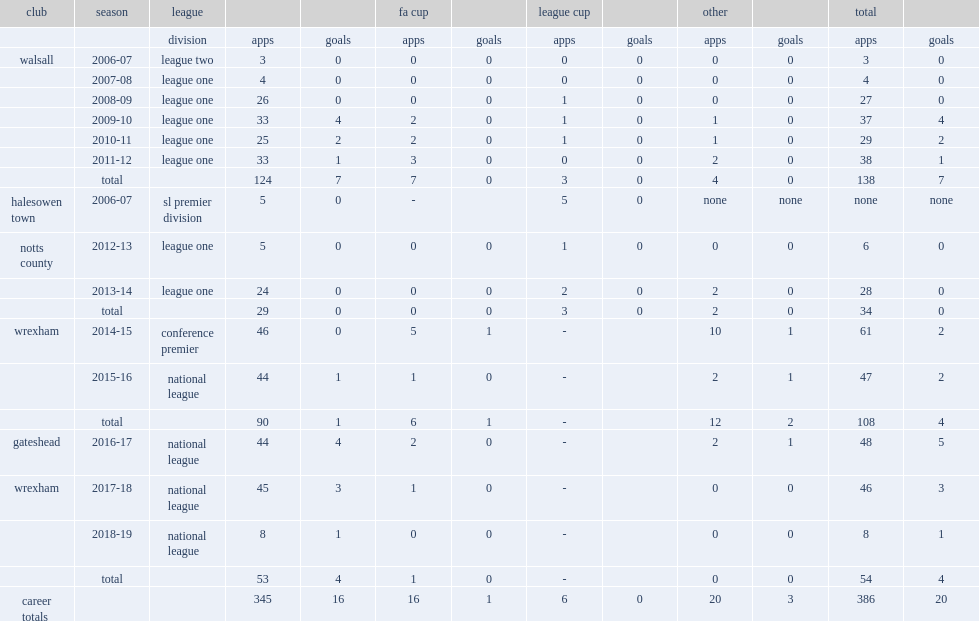Which club did smith play for in 2015-16? Wrexham. 